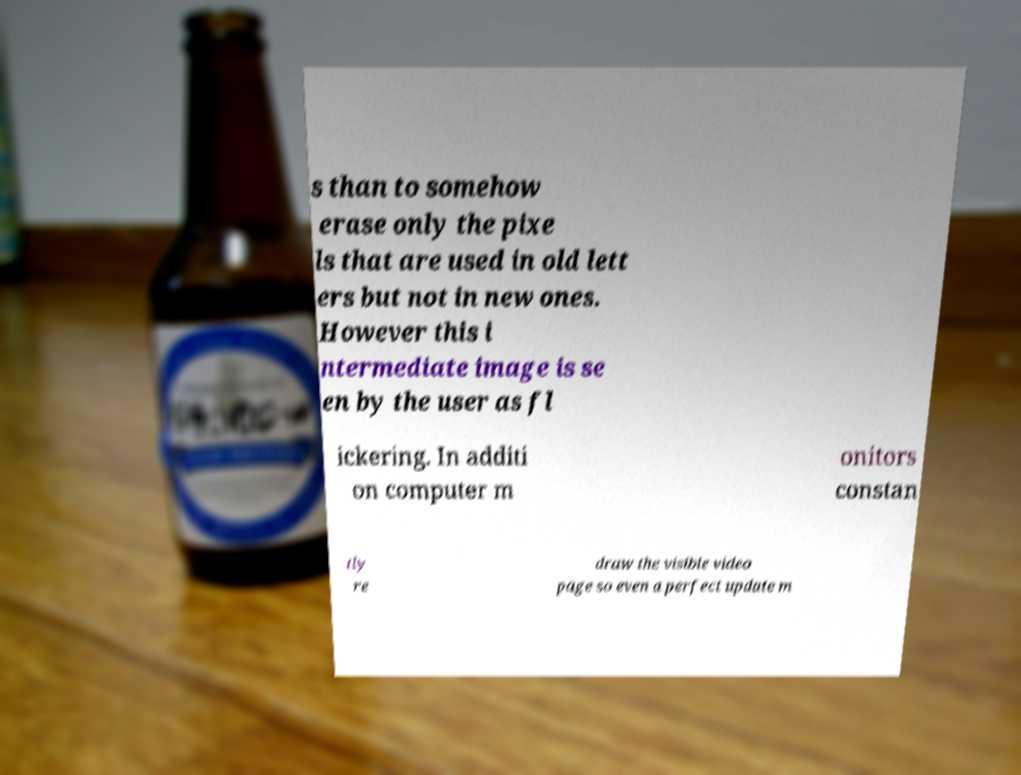For documentation purposes, I need the text within this image transcribed. Could you provide that? s than to somehow erase only the pixe ls that are used in old lett ers but not in new ones. However this i ntermediate image is se en by the user as fl ickering. In additi on computer m onitors constan tly re draw the visible video page so even a perfect update m 